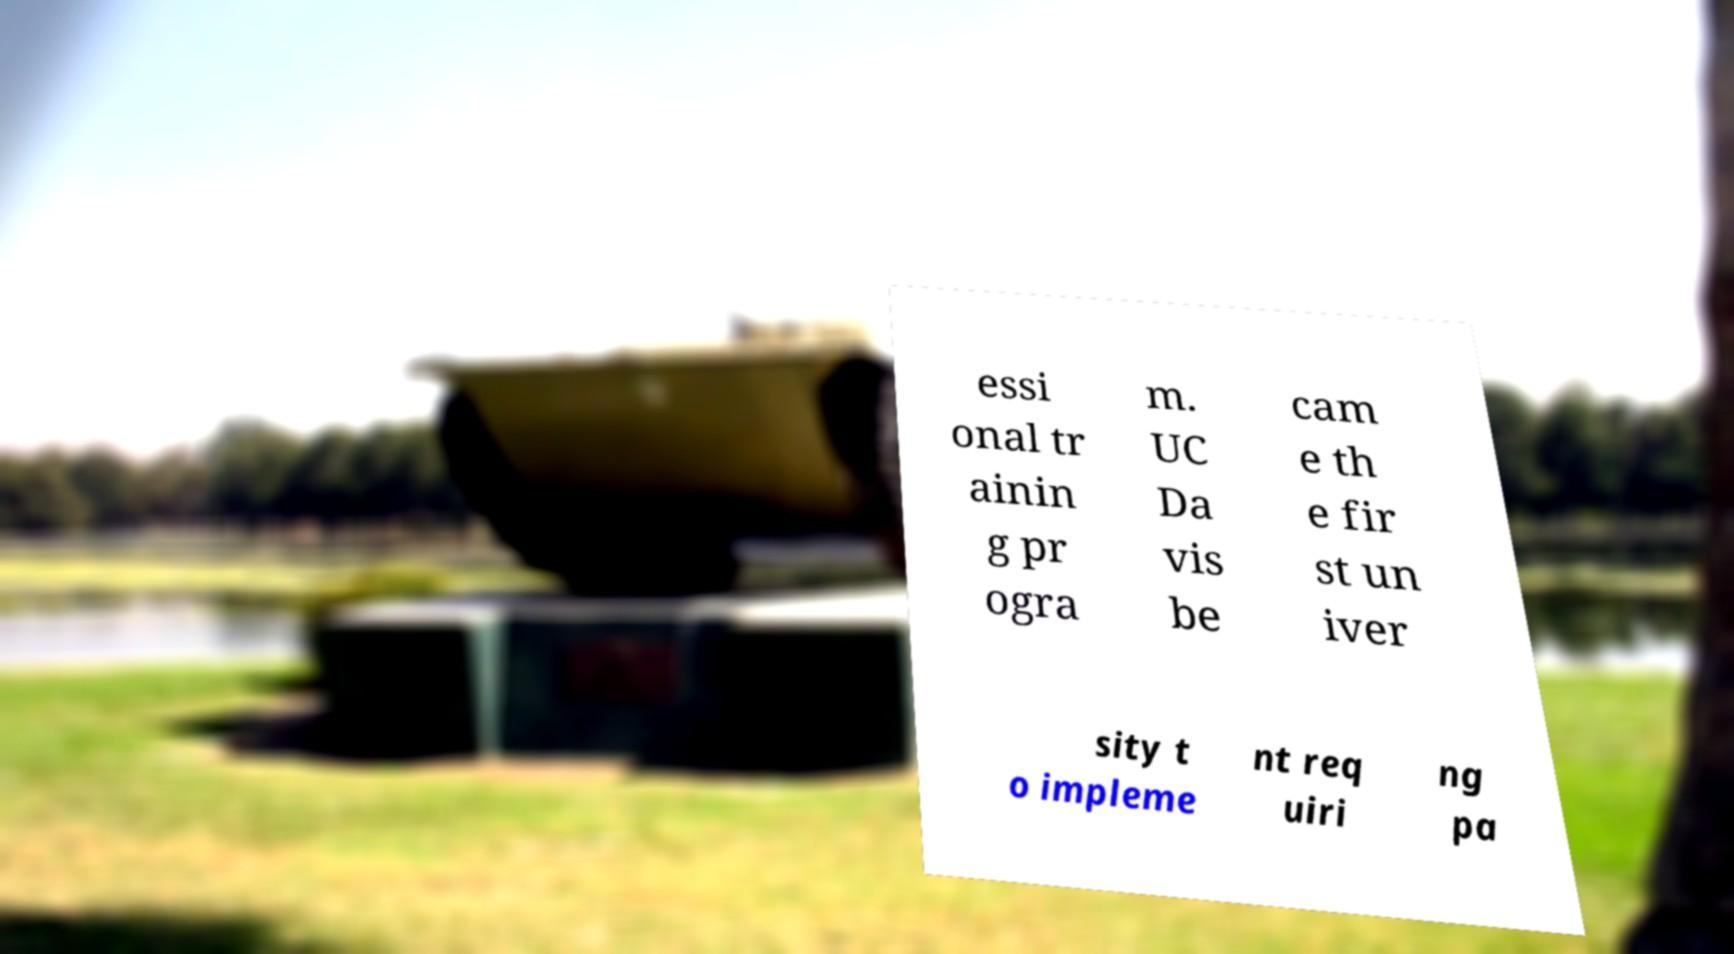Could you assist in decoding the text presented in this image and type it out clearly? essi onal tr ainin g pr ogra m. UC Da vis be cam e th e fir st un iver sity t o impleme nt req uiri ng pa 